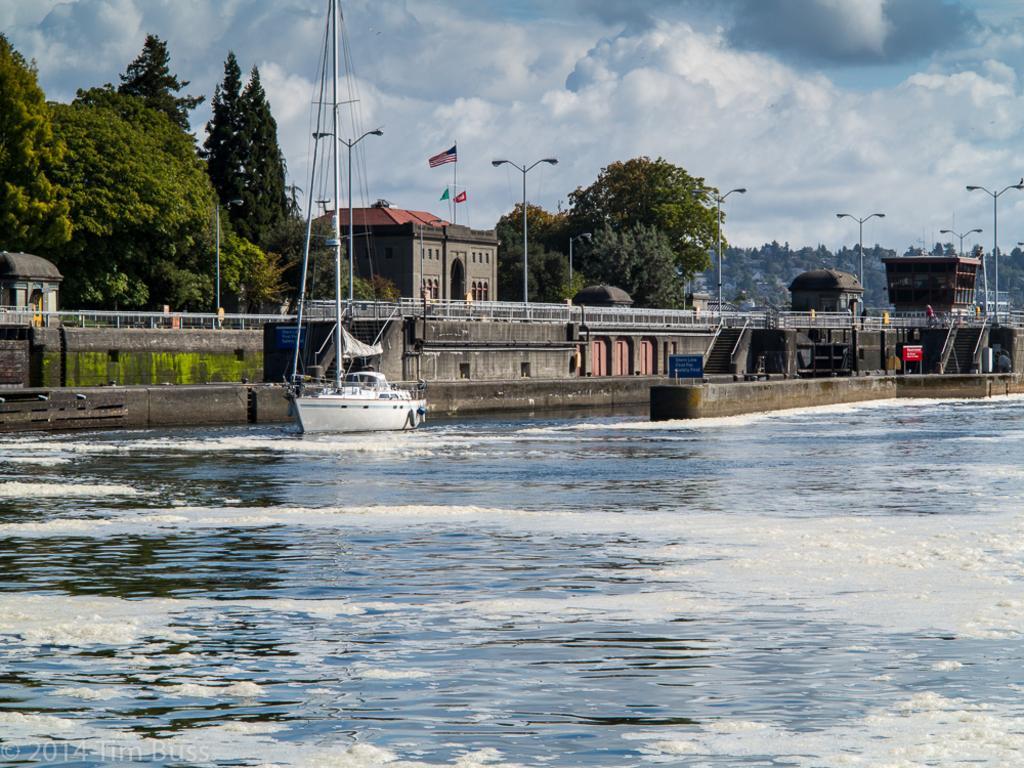Can you describe this image briefly? In this image I can see the water, a boat which is white in color on the surface of the water, few stairs, the railing, few buildings, few poles, few flags, and few trees which are green in color. In the background I can see the sky. 